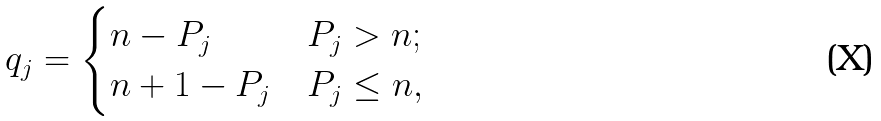Convert formula to latex. <formula><loc_0><loc_0><loc_500><loc_500>q _ { j } & = \begin{cases} n - P _ { j } & P _ { j } > n ; \\ n + 1 - P _ { j } & P _ { j } \leq n , \end{cases}</formula> 